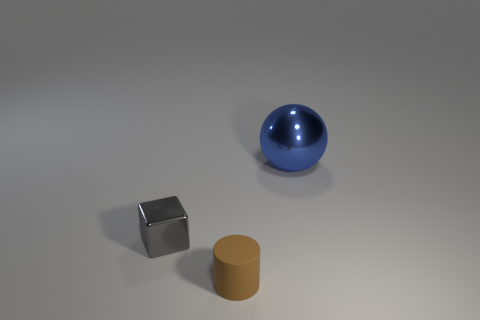Subtract all balls. How many objects are left? 2 Subtract 1 balls. How many balls are left? 0 Add 1 tiny blocks. How many objects exist? 4 Add 2 small blue shiny cylinders. How many small blue shiny cylinders exist? 2 Subtract 0 blue cylinders. How many objects are left? 3 Subtract all red spheres. Subtract all green cylinders. How many spheres are left? 1 Subtract all brown rubber cylinders. Subtract all big metal things. How many objects are left? 1 Add 2 small cylinders. How many small cylinders are left? 3 